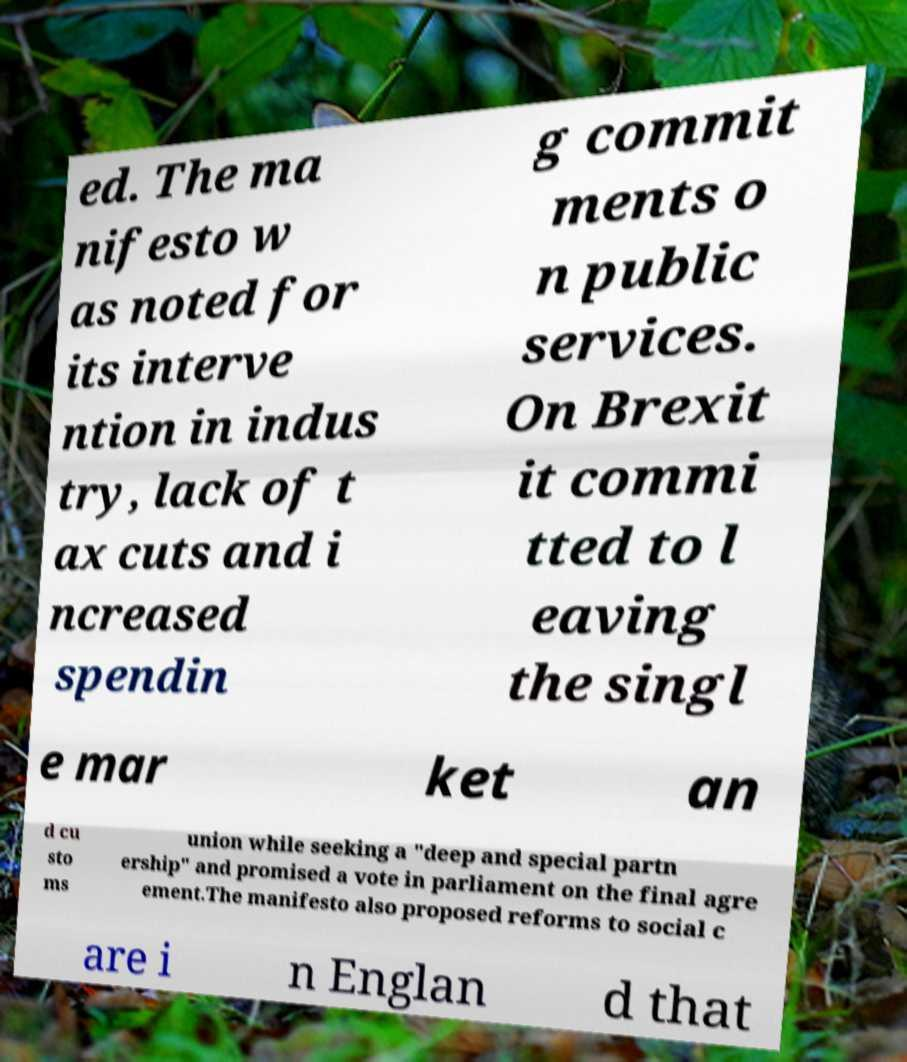There's text embedded in this image that I need extracted. Can you transcribe it verbatim? ed. The ma nifesto w as noted for its interve ntion in indus try, lack of t ax cuts and i ncreased spendin g commit ments o n public services. On Brexit it commi tted to l eaving the singl e mar ket an d cu sto ms union while seeking a "deep and special partn ership" and promised a vote in parliament on the final agre ement.The manifesto also proposed reforms to social c are i n Englan d that 